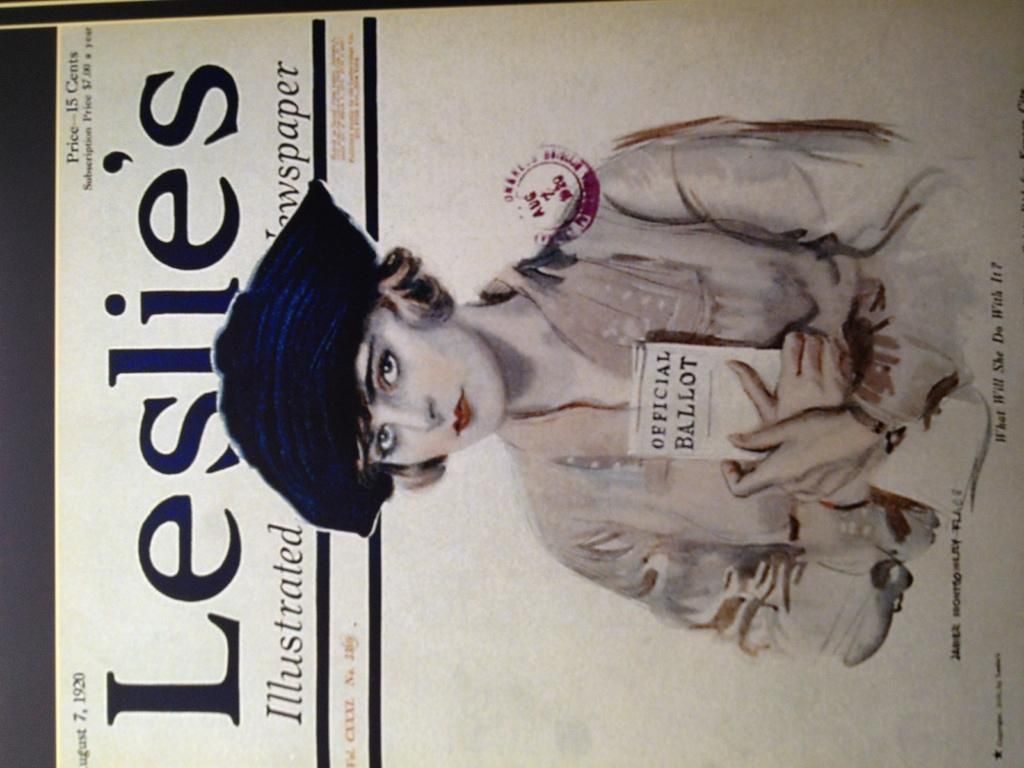What is featured on the poster in the image? There is a poster in the image that contains a painting of a woman. Can you describe the woman in the painting? The woman is standing in the painting and is wearing a cap. What is the woman holding in the painting? The woman is holding a newspaper in the painting. How many grapes are hanging from the tree in the image? There is no tree or grapes present in the image; the image features a poster with a painting of a woman. 